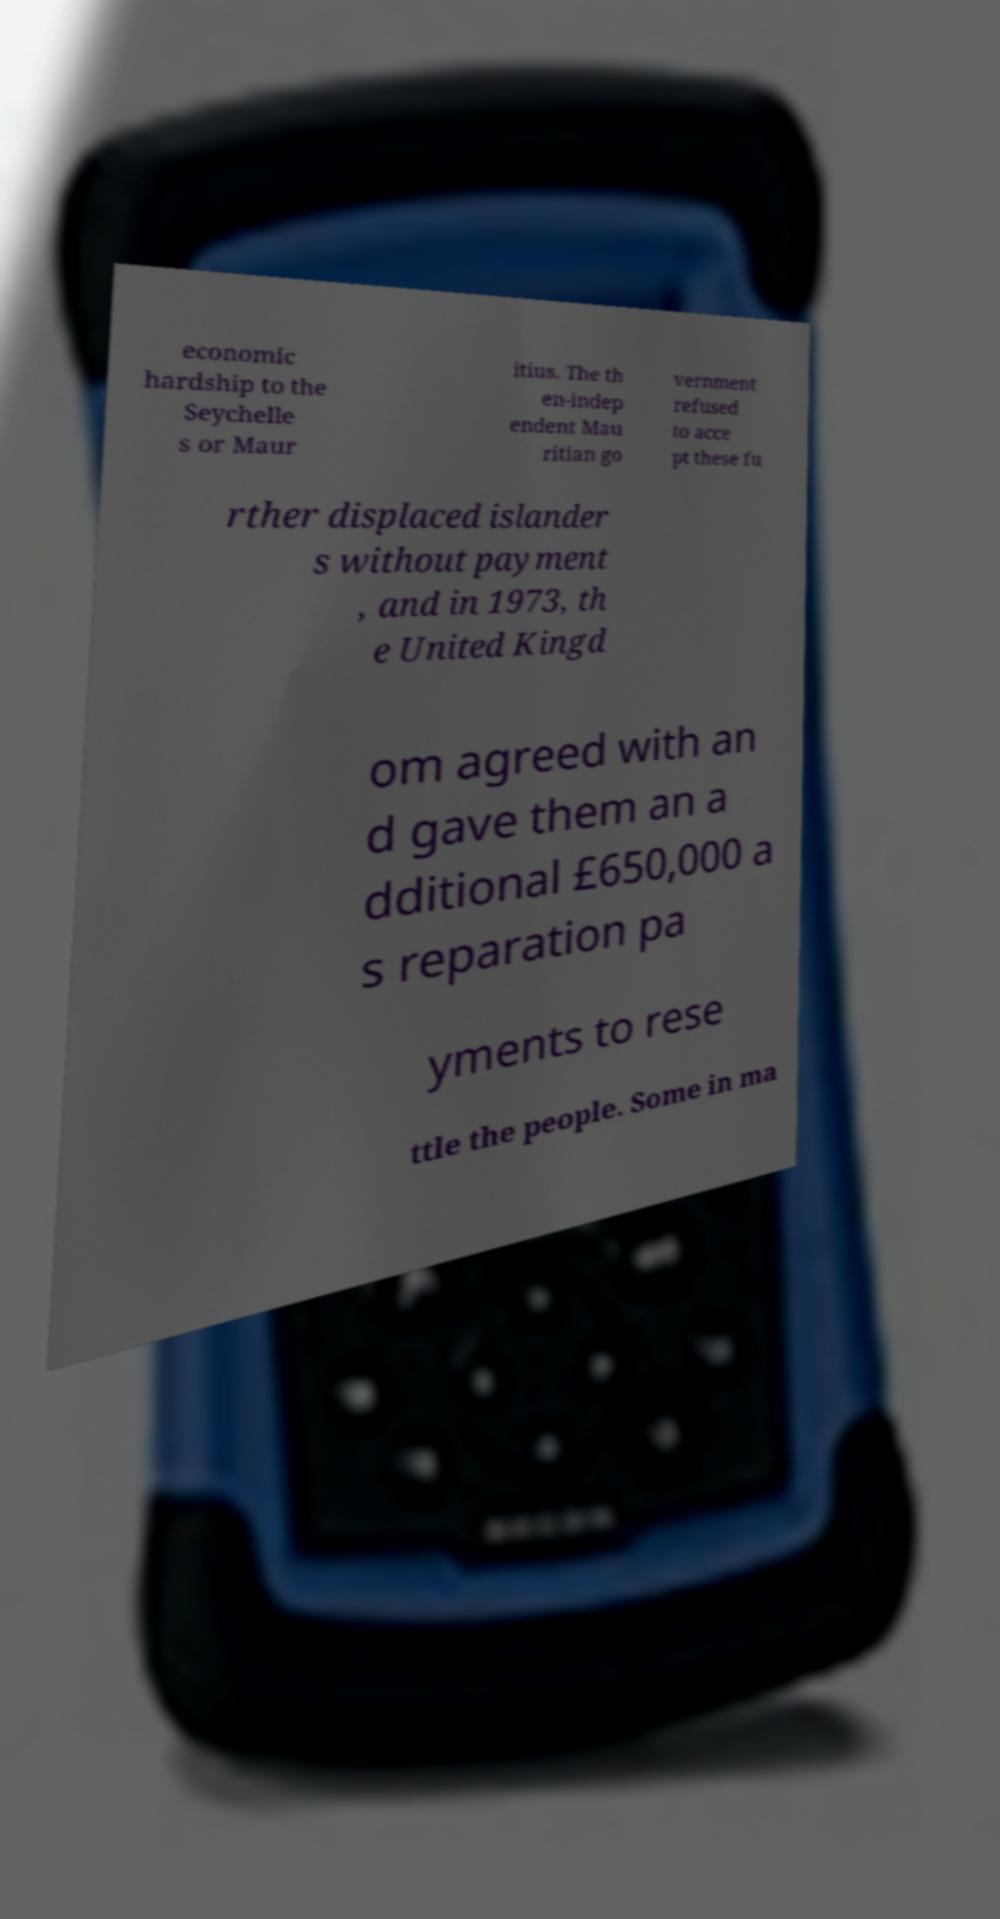For documentation purposes, I need the text within this image transcribed. Could you provide that? economic hardship to the Seychelle s or Maur itius. The th en-indep endent Mau ritian go vernment refused to acce pt these fu rther displaced islander s without payment , and in 1973, th e United Kingd om agreed with an d gave them an a dditional £650,000 a s reparation pa yments to rese ttle the people. Some in ma 